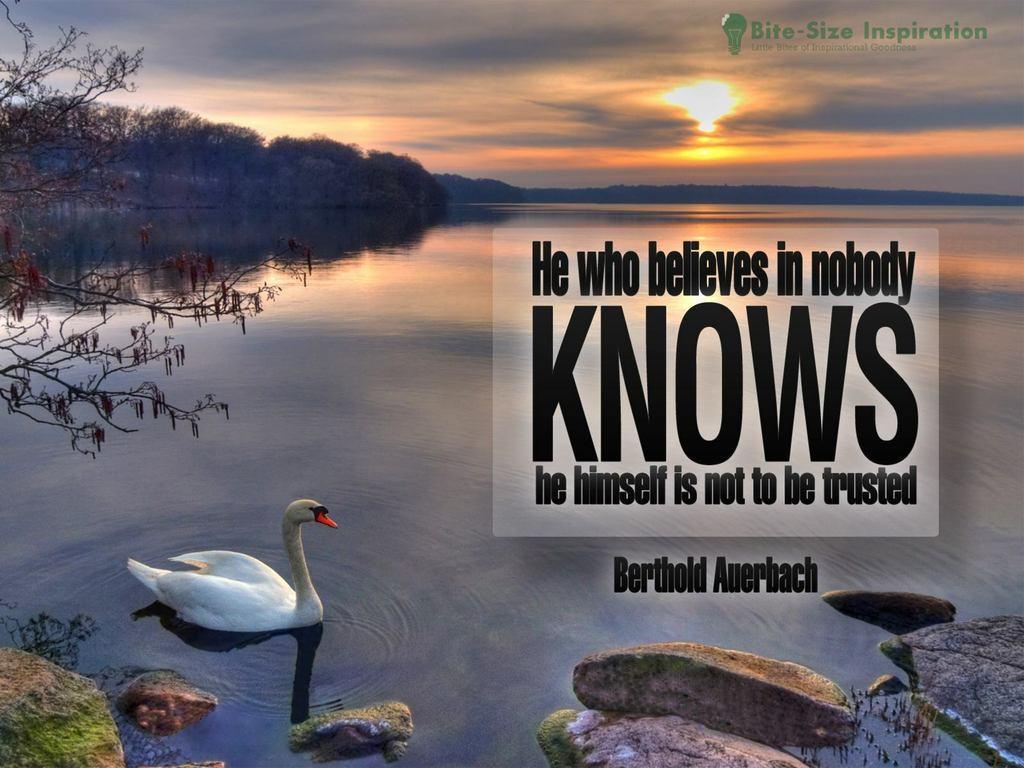Could you give a brief overview of what you see in this image? In front of the image there are rocks, beside the rocks there is a swan in the water, on the left side of the image there is a tree, in the background of the image there are trees and mountains, at the top of the image there are clouds and sun in the sky. On the image there are some text and logo. 